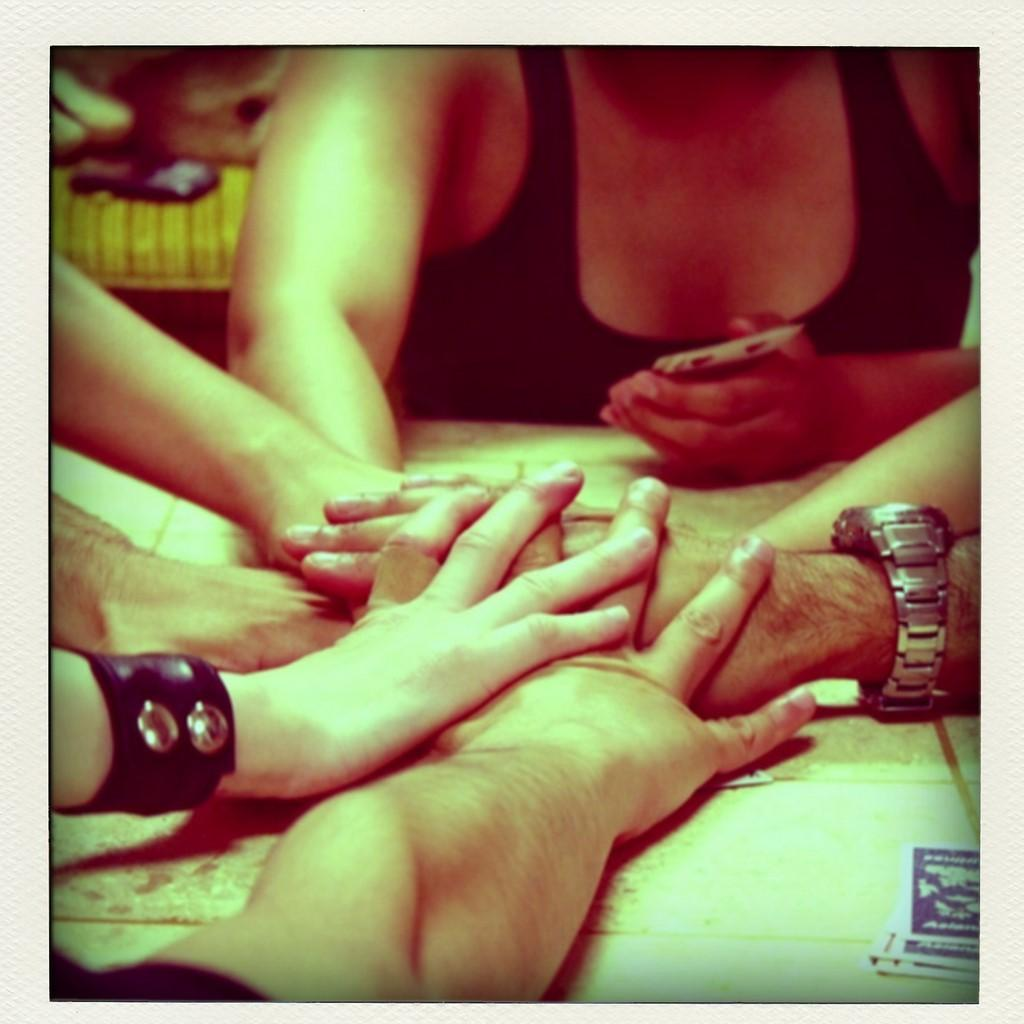How many people are present in the image? There are many people in the image. What are the people doing with their hands in the image? The people's hands are stacked one above the other. What type of salt can be seen on the band in the image? There is no salt or band present in the image. 